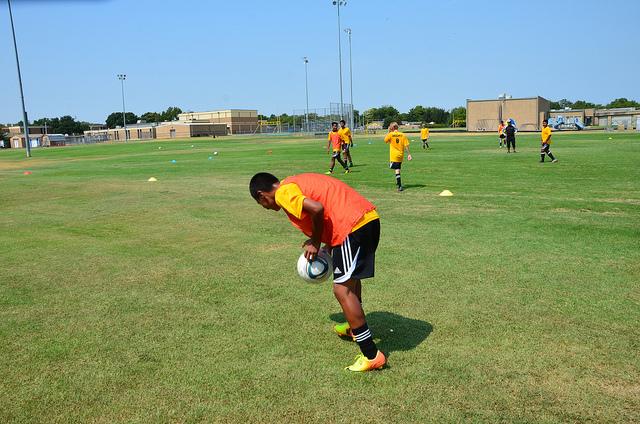Is this indoors or outdoors?
Short answer required. Outdoors. Whose turn is it to kick?
Give a very brief answer. Player. What sport are they playing?
Concise answer only. Soccer. 